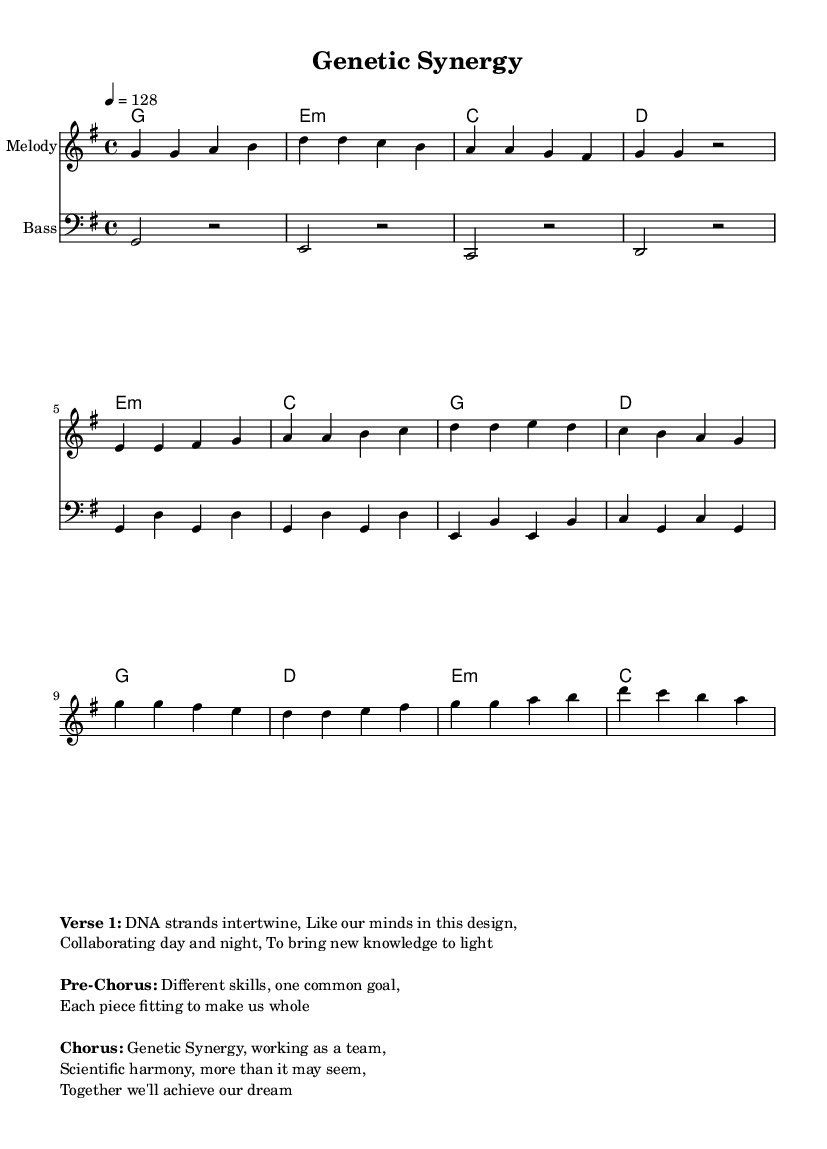What is the key signature of this music? The key signature is G major, which has one sharp (F#). This can be determined by looking at the 'key' section in the global variable, where it specifies 'g major'.
Answer: G major What is the time signature of this music? The time signature is 4/4, as indicated in the global variable section where it states '\time 4/4'. This indicates that there are 4 beats in each measure and the quarter note gets one beat.
Answer: 4/4 What is the tempo of this music? The tempo is 128 beats per minute, as stated in the global declaration where it is written '\tempo 4 = 128'. This indicates the speed at which the piece should be played.
Answer: 128 How many measures are in the verse section? The verse section consists of four measures, which can be counted based on the melody notes provided in that section. Each group of notes followed by a bar line indicates a measure.
Answer: 4 What is the primary theme of the lyrics in this piece? The primary theme revolves around scientific collaboration and teamwork, as reflected in the lyrics that discuss DNA strands, collaboration, and achieving common goals together. This theme aligns with the title "Genetic Synergy."
Answer: Scientific collaboration Which musical elements are combined in the pre-chorus? The pre-chorus combines different skills and a common goal, indicated by the lyrics which express teamwork and unity in achieving a shared purpose. This is a thematic element common in many K-Pop songs.
Answer: Different skills, one common goal What genre does this music belong to? This piece belongs to the K-Pop genre, characterized by its upbeat tempo and focus on themes of collaboration and teamwork, which is common in K-Pop tracks. The energetic rhythm and pop-oriented structure also categorize it as such.
Answer: K-Pop 